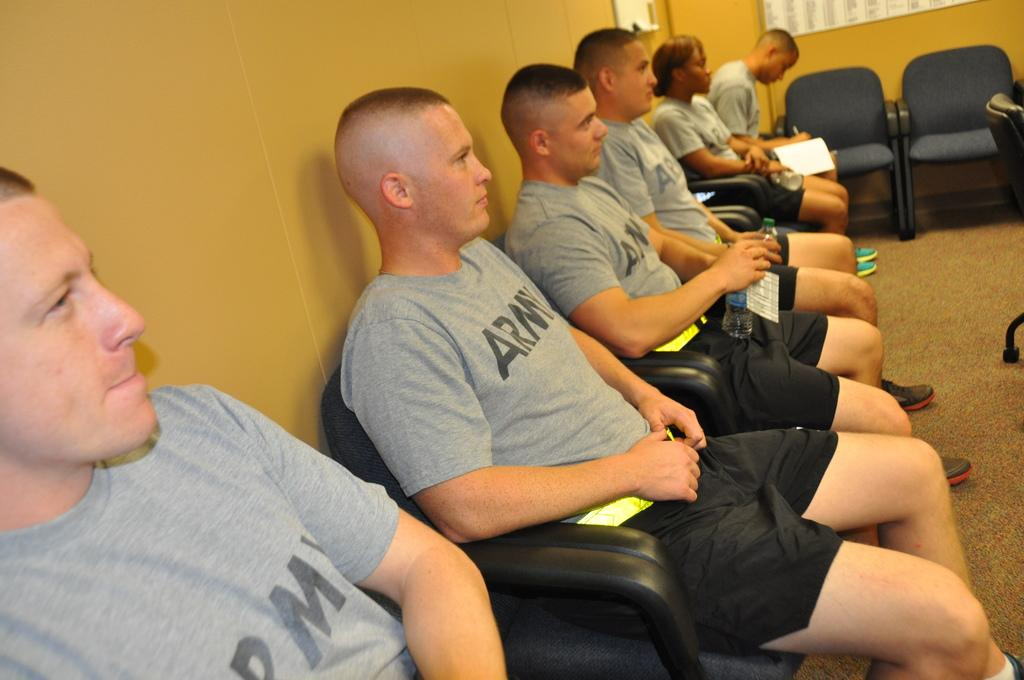What can be seen in the background of the image? There is a wall in the background of the image. What type of furniture is present in the image? There are chairs in the image. What are the people in the image doing? People are sitting on the chairs. What might the people be holding in their hands? Some people are holding water bottles in their hands. What type of surface is visible in the image? The image shows a floor. What type of orange is being peeled by the person in the image? There is no orange present in the image; people are sitting on chairs and holding water bottles. 